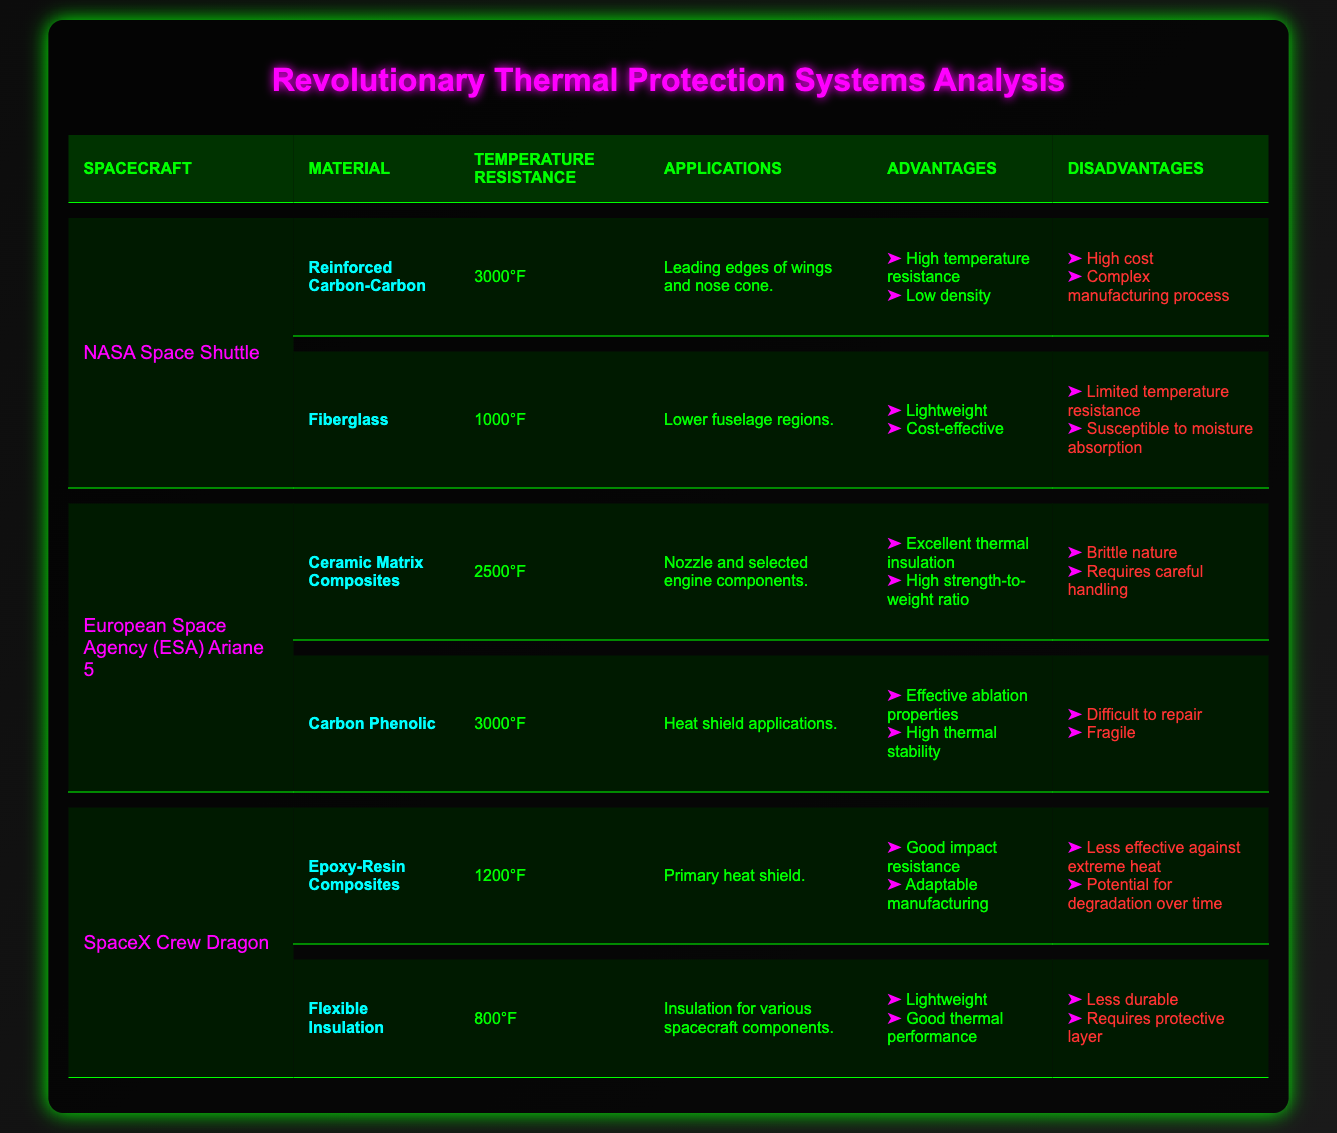What is the temperature resistance of the Reinforced Carbon-Carbon material? From the table, we can find that under the NASA Space Shuttle section, the Reinforced Carbon-Carbon material has a temperature resistance listed as 3000°F.
Answer: 3000°F What are the advantages of using Fiberglass in the NASA Space Shuttle? In the table, for the Fiberglass material listed under the NASA Space Shuttle, the advantages are: lightweight and cost-effective.
Answer: Lightweight, cost-effective Is Ceramic Matrix Composites used in the SpaceX Crew Dragon? Referring to the table, Ceramic Matrix Composites is not listed under the SpaceX Crew Dragon; it only appears under the European Space Agency (ESA) Ariane 5, which means it is not used in SpaceX Crew Dragon.
Answer: No Which spacecraft has the lowest temperature resistance material listed, and what is that temperature? Looking at the temperature resistance values in the table, the lowest temperature resistance is found in the Flexible Insulation material under the SpaceX Crew Dragon, which is 800°F. Therefore, the spacecraft with the lowest temperature resistance material is SpaceX Crew Dragon, and the temperature is 800°F.
Answer: SpaceX Crew Dragon, 800°F If we consider the material with the highest temperature resistance, which spacecraft is it associated with, and what advantages does it offer? The highest temperature resistance listed is 3000°F, which is associated with both Reinforced Carbon-Carbon (NASA Space Shuttle) and Carbon Phenolic (European Space Agency Ariane 5). The advantages of Reinforced Carbon-Carbon are high temperature resistance and low density, while Carbon Phenolic has effective ablation properties and high thermal stability.
Answer: NASA Space Shuttle and European Space Agency Ariane 5; advantages include high temperature resistance, low density and effective ablation properties, high thermal stability 